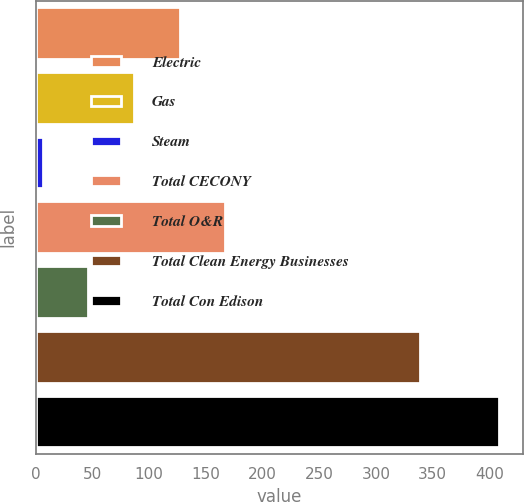Convert chart to OTSL. <chart><loc_0><loc_0><loc_500><loc_500><bar_chart><fcel>Electric<fcel>Gas<fcel>Steam<fcel>Total CECONY<fcel>Total O&R<fcel>Total Clean Energy Businesses<fcel>Total Con Edison<nl><fcel>126.9<fcel>86.6<fcel>6<fcel>167.2<fcel>46.3<fcel>339<fcel>409<nl></chart> 